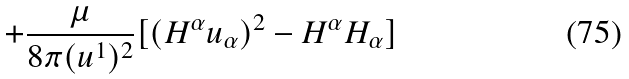<formula> <loc_0><loc_0><loc_500><loc_500>+ \frac { \mu } { 8 \pi ( u ^ { 1 } ) ^ { 2 } } [ ( H ^ { \alpha } u _ { \alpha } ) ^ { 2 } - H ^ { \alpha } H _ { \alpha } ]</formula> 